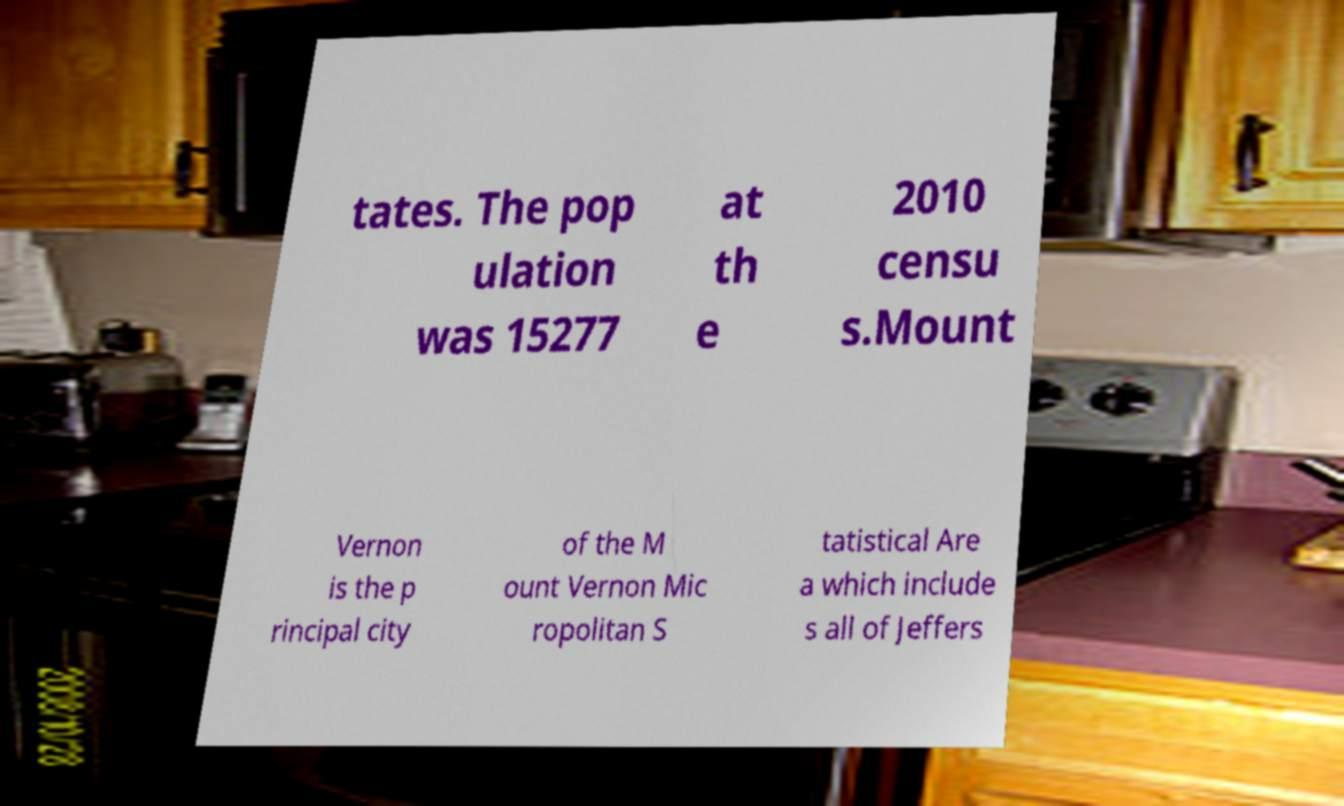Can you accurately transcribe the text from the provided image for me? tates. The pop ulation was 15277 at th e 2010 censu s.Mount Vernon is the p rincipal city of the M ount Vernon Mic ropolitan S tatistical Are a which include s all of Jeffers 